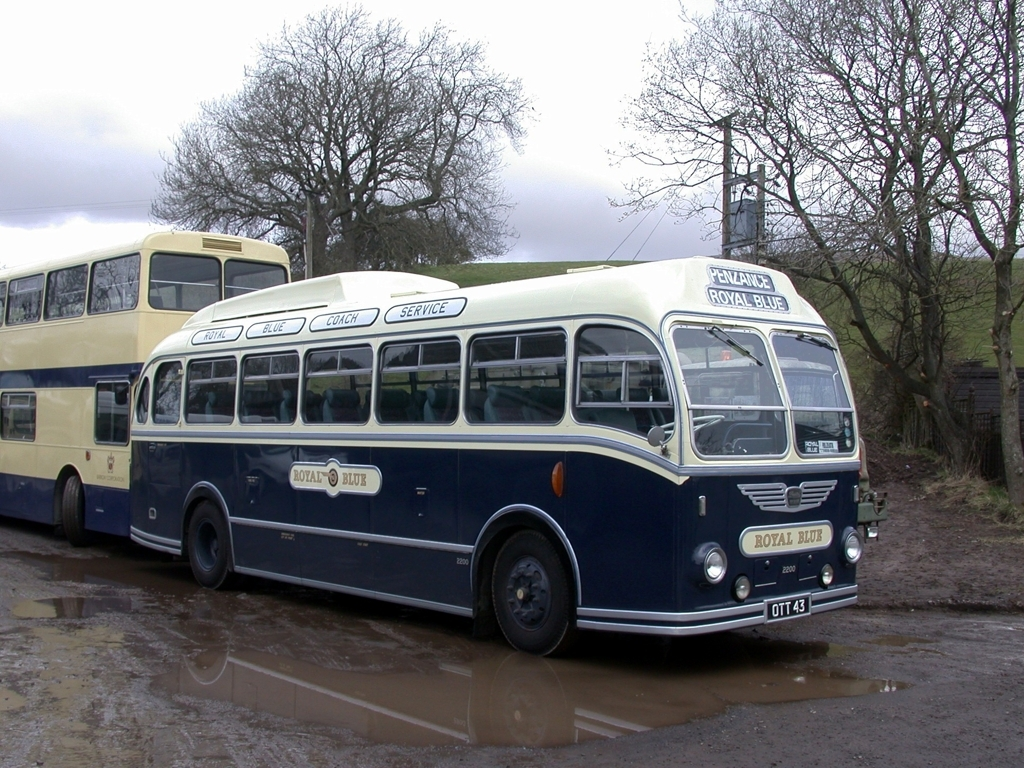What can you say about the destination mentioned on the front of the bus? The destination 'Penzance' displayed on the front of the bus indicates that this bus served routes in or around Penzance, which is a town located at the western end of Cornwall, England. It suggests that the bus line provided regional service, connecting smaller towns to larger hubs. 